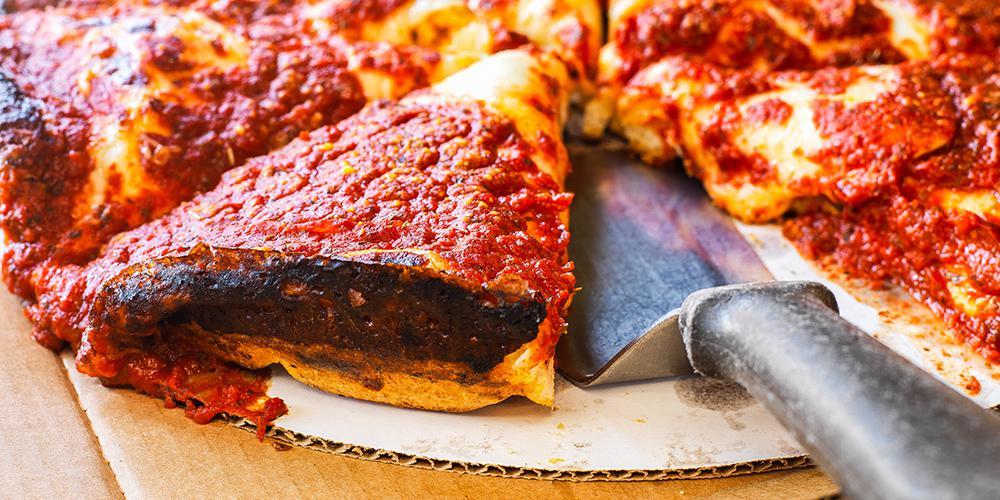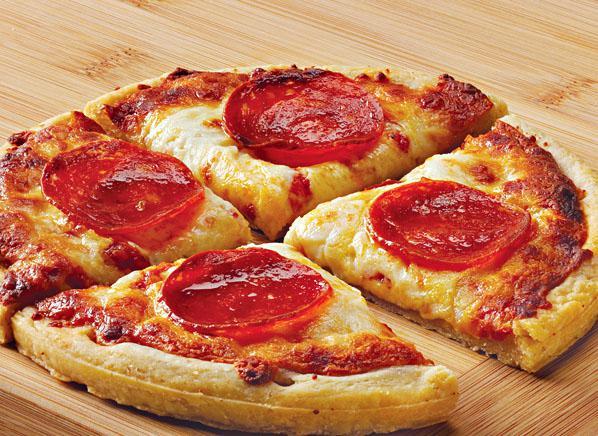The first image is the image on the left, the second image is the image on the right. Assess this claim about the two images: "None of the pizza shown has pepperoni on it.". Correct or not? Answer yes or no. No. 